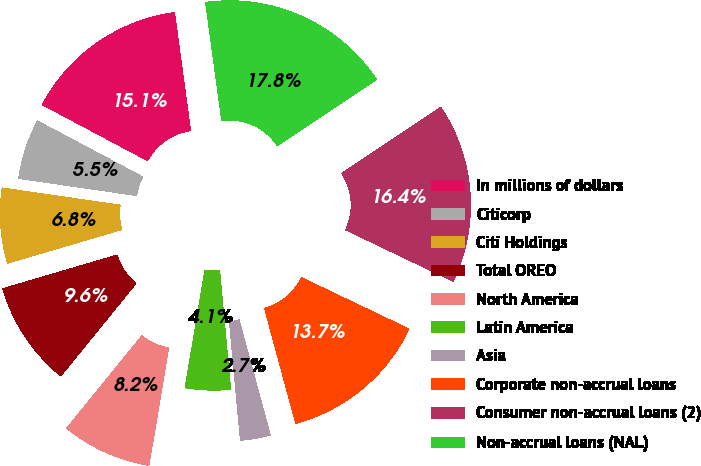Convert chart to OTSL. <chart><loc_0><loc_0><loc_500><loc_500><pie_chart><fcel>In millions of dollars<fcel>Citicorp<fcel>Citi Holdings<fcel>Total OREO<fcel>North America<fcel>Latin America<fcel>Asia<fcel>Corporate non-accrual loans<fcel>Consumer non-accrual loans (2)<fcel>Non-accrual loans (NAL)<nl><fcel>15.07%<fcel>5.48%<fcel>6.85%<fcel>9.59%<fcel>8.22%<fcel>4.11%<fcel>2.74%<fcel>13.7%<fcel>16.44%<fcel>17.81%<nl></chart> 